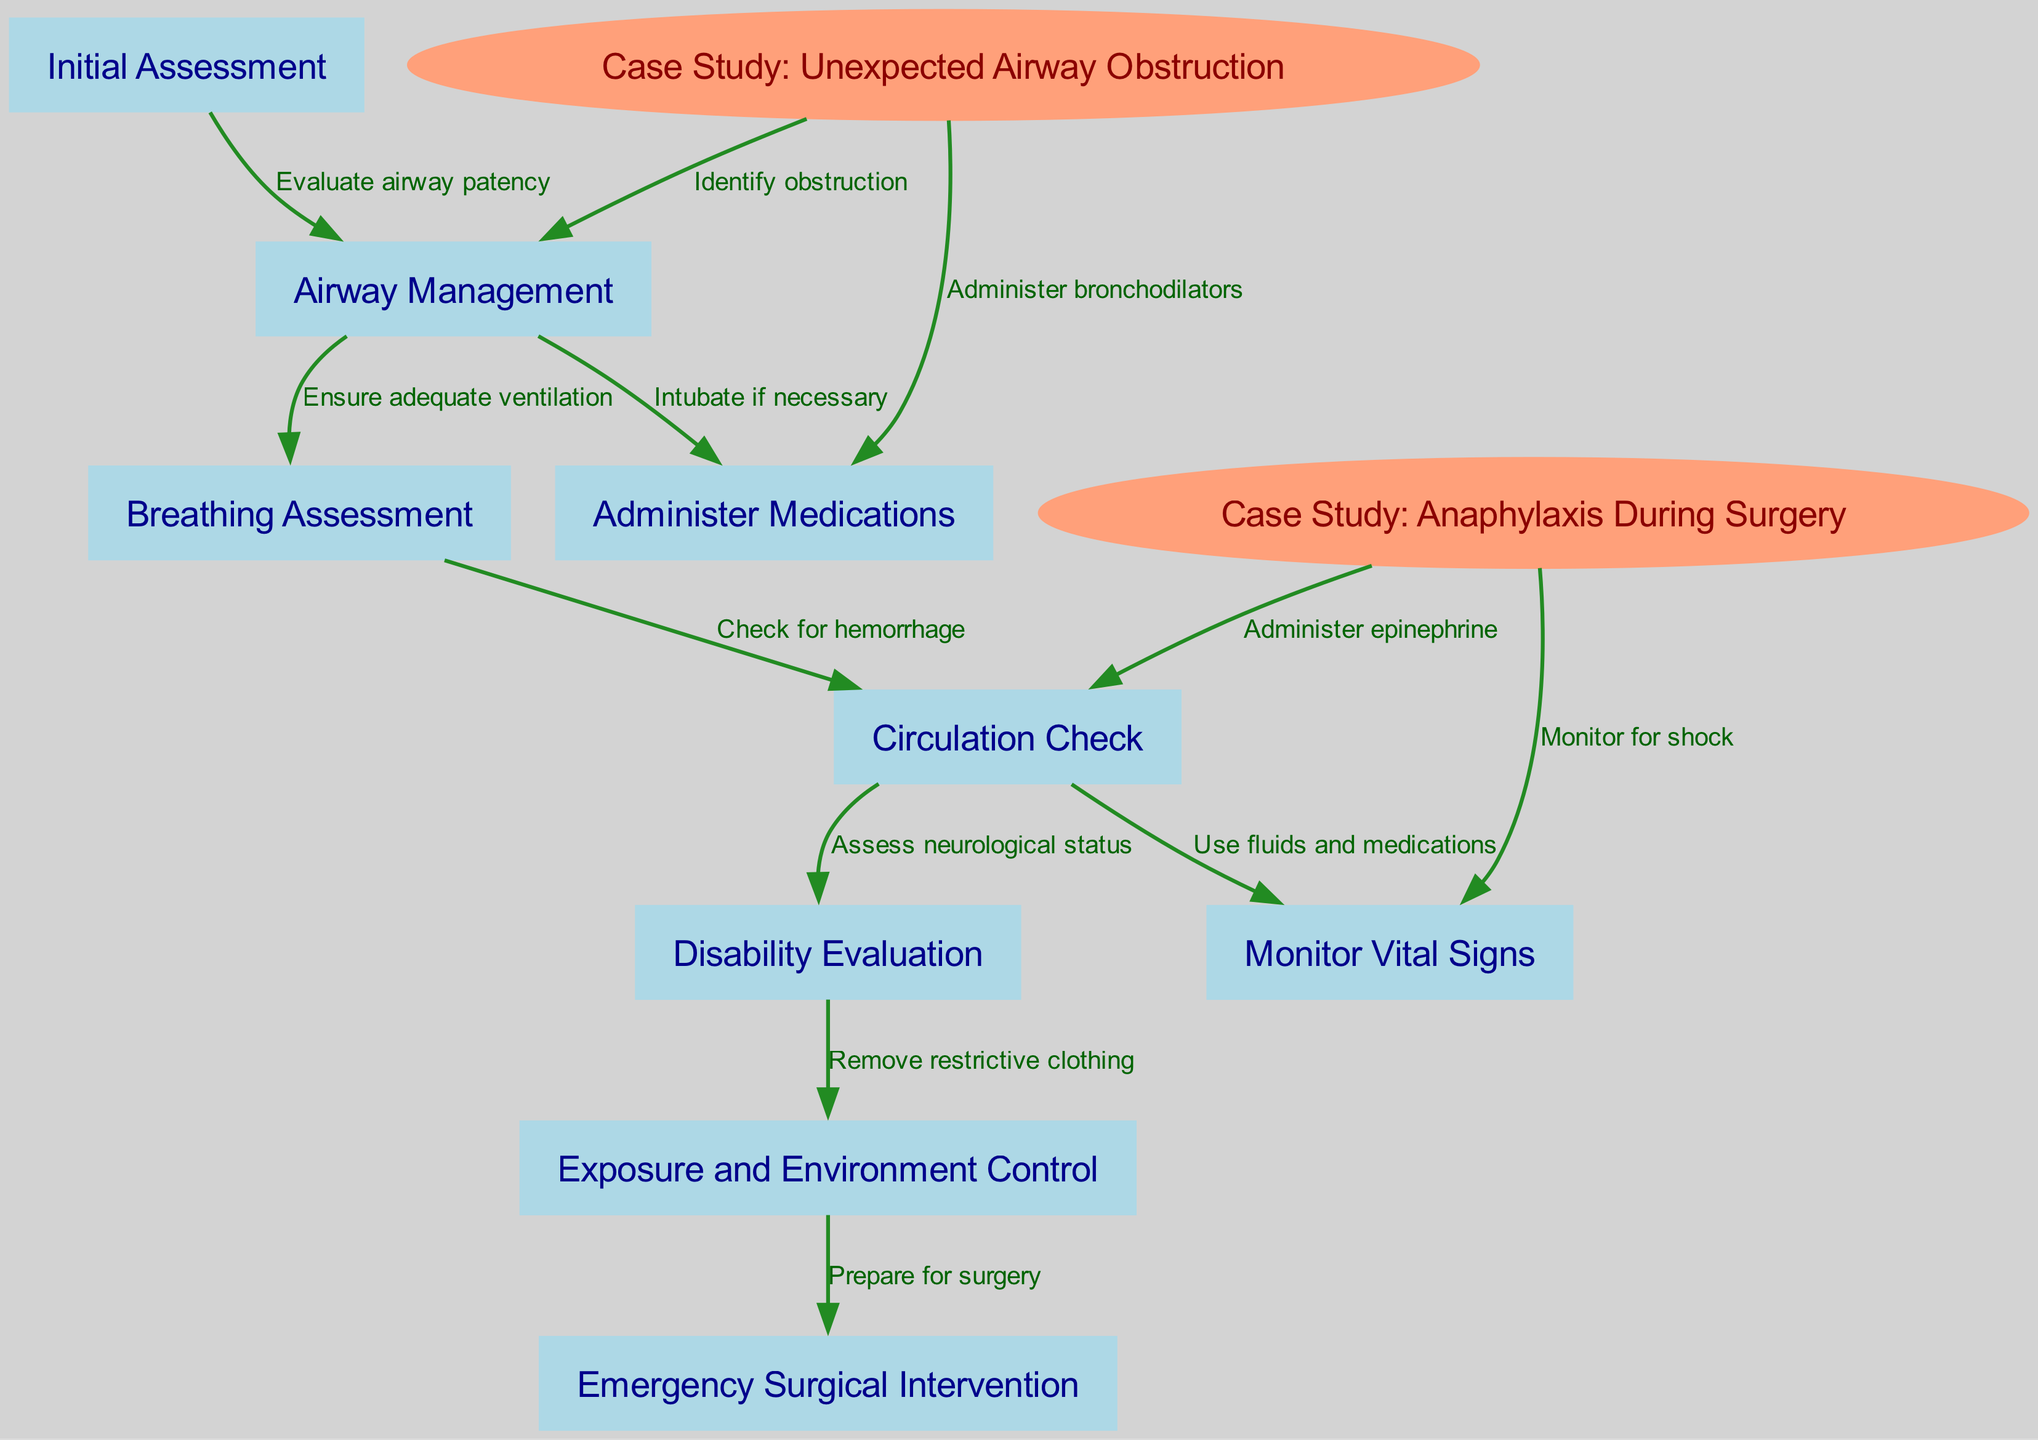What is the first step in the crisis management protocol? The diagram indicates that the first step is "Initial Assessment." This is shown as the starting node in the flow of the protocol.
Answer: Initial Assessment How many case studies are included in the diagram? The diagram presents two specific nodes labeled as case studies: "Case Study: Unexpected Airway Obstruction" and "Case Study: Anaphylaxis During Surgery." Counting these nodes gives us two case studies total.
Answer: 2 What occurs after the "Airway Management" node? The flow from "Airway Management" proceeds to "Breathing Assessment," as shown by the directed edge labeled "Ensure adequate ventilation."
Answer: Breathing Assessment What medication is administered in response to "Anaphylaxis During Surgery"? The diagram shows that "Epinephrine" is specifically administered as part of the response to the case of "Anaphylaxis During Surgery." This is indicated by the edge leading to "Administer epinephrine."
Answer: Epinephrine What action is taken if intubation is necessary? The diagram specifies that if intubation is necessary, the action taken is "Intubate if necessary," which directly follows the "Airway Management" node.
Answer: Intubate if necessary What is the last action in the "Emergency Surgical Intervention" process? According to the diagram, the "Emergency Surgical Intervention" follows the "Exposure and Environment Control" node, indicating that preparation for surgery is the next step in this critical situation.
Answer: Prepare for surgery What is checked after evaluating neurological status? After assessing the neurological status, the flow indicates that the next step is "Exposure and Environment Control," which involves removing restrictive clothing as part of the protocol.
Answer: Exposure and Environment Control Which node indicates the use of bronchodilators? The node "Administer bronchodilators" is connected to "Case Study: Unexpected Airway Obstruction," highlighting its specific role in addressing this particular emergency situation.
Answer: Administer bronchodilators What is the flow direction from "Circulation Check"? The "Circulation Check" node flows to both "Monitor Vital Signs" and "Disability Evaluation," showing that both assessments are immediate subsequent actions in the protocol after checking circulation.
Answer: Monitor Vital Signs, Disability Evaluation 